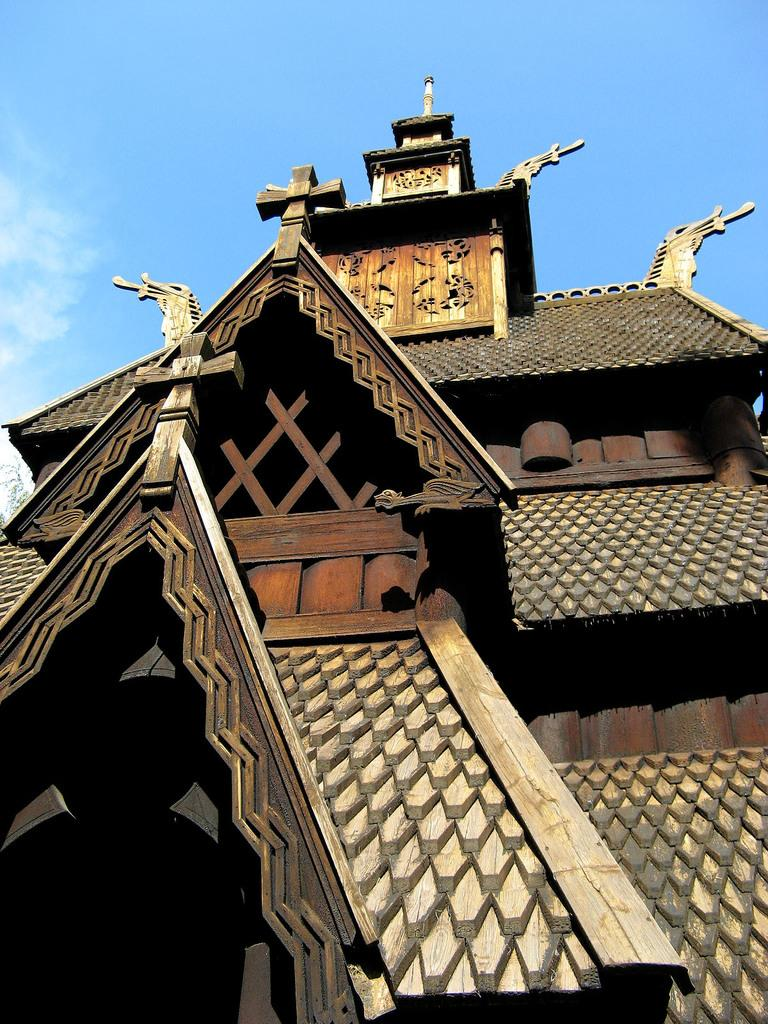What type of structures can be seen in the image? There are buildings in the image. What part of the natural environment is visible in the image? The sky is visible in the image. What can be seen in the sky? Clouds are present in the sky. How many chains can be seen connecting the buildings in the image? There are no chains connecting the buildings in the image. Are there any bikes visible in the image? There are no bikes present in the image. 